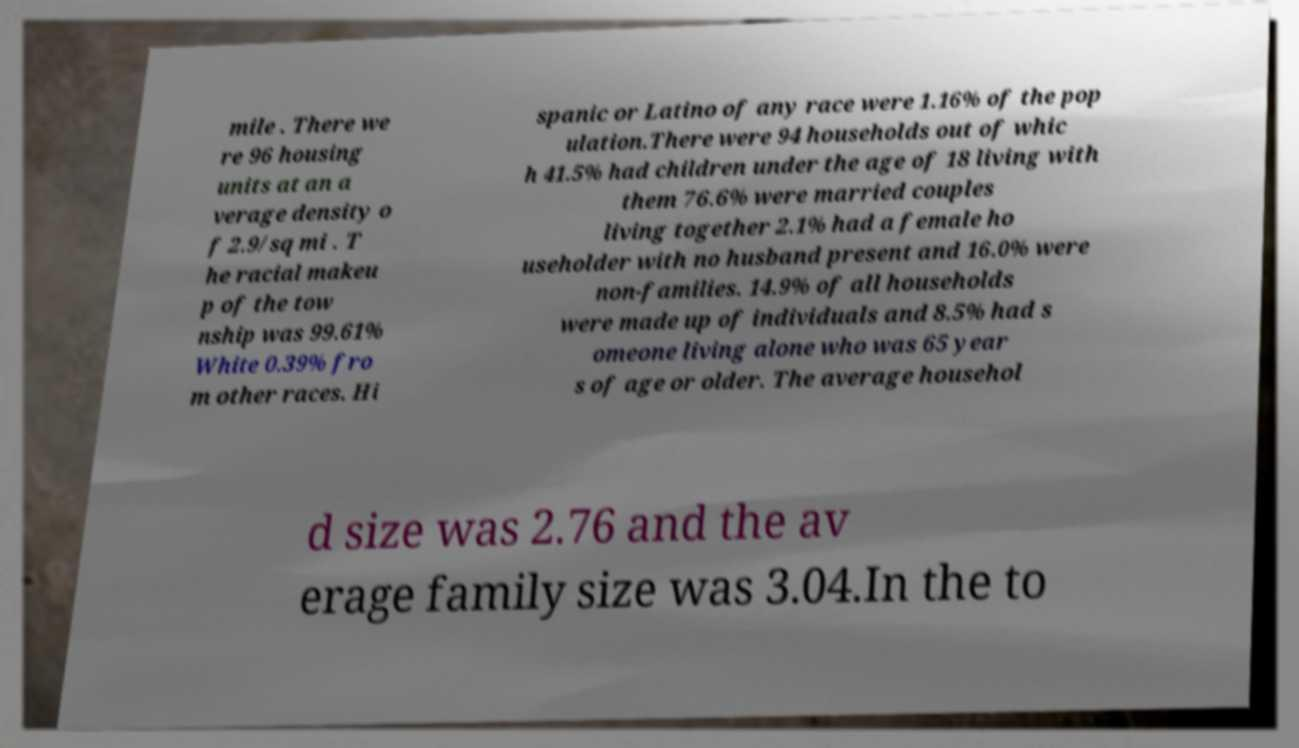Could you extract and type out the text from this image? mile . There we re 96 housing units at an a verage density o f 2.9/sq mi . T he racial makeu p of the tow nship was 99.61% White 0.39% fro m other races. Hi spanic or Latino of any race were 1.16% of the pop ulation.There were 94 households out of whic h 41.5% had children under the age of 18 living with them 76.6% were married couples living together 2.1% had a female ho useholder with no husband present and 16.0% were non-families. 14.9% of all households were made up of individuals and 8.5% had s omeone living alone who was 65 year s of age or older. The average househol d size was 2.76 and the av erage family size was 3.04.In the to 